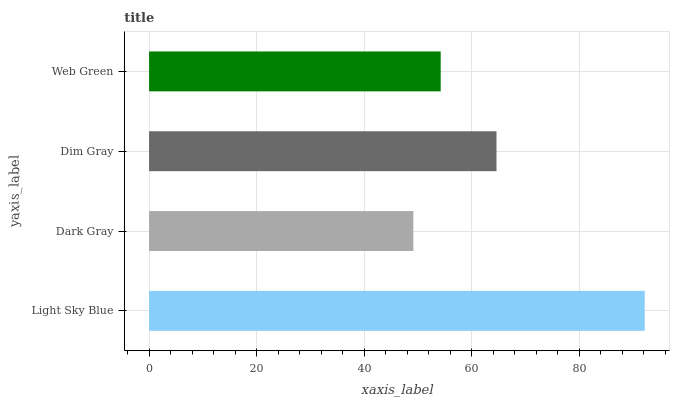Is Dark Gray the minimum?
Answer yes or no. Yes. Is Light Sky Blue the maximum?
Answer yes or no. Yes. Is Dim Gray the minimum?
Answer yes or no. No. Is Dim Gray the maximum?
Answer yes or no. No. Is Dim Gray greater than Dark Gray?
Answer yes or no. Yes. Is Dark Gray less than Dim Gray?
Answer yes or no. Yes. Is Dark Gray greater than Dim Gray?
Answer yes or no. No. Is Dim Gray less than Dark Gray?
Answer yes or no. No. Is Dim Gray the high median?
Answer yes or no. Yes. Is Web Green the low median?
Answer yes or no. Yes. Is Web Green the high median?
Answer yes or no. No. Is Light Sky Blue the low median?
Answer yes or no. No. 